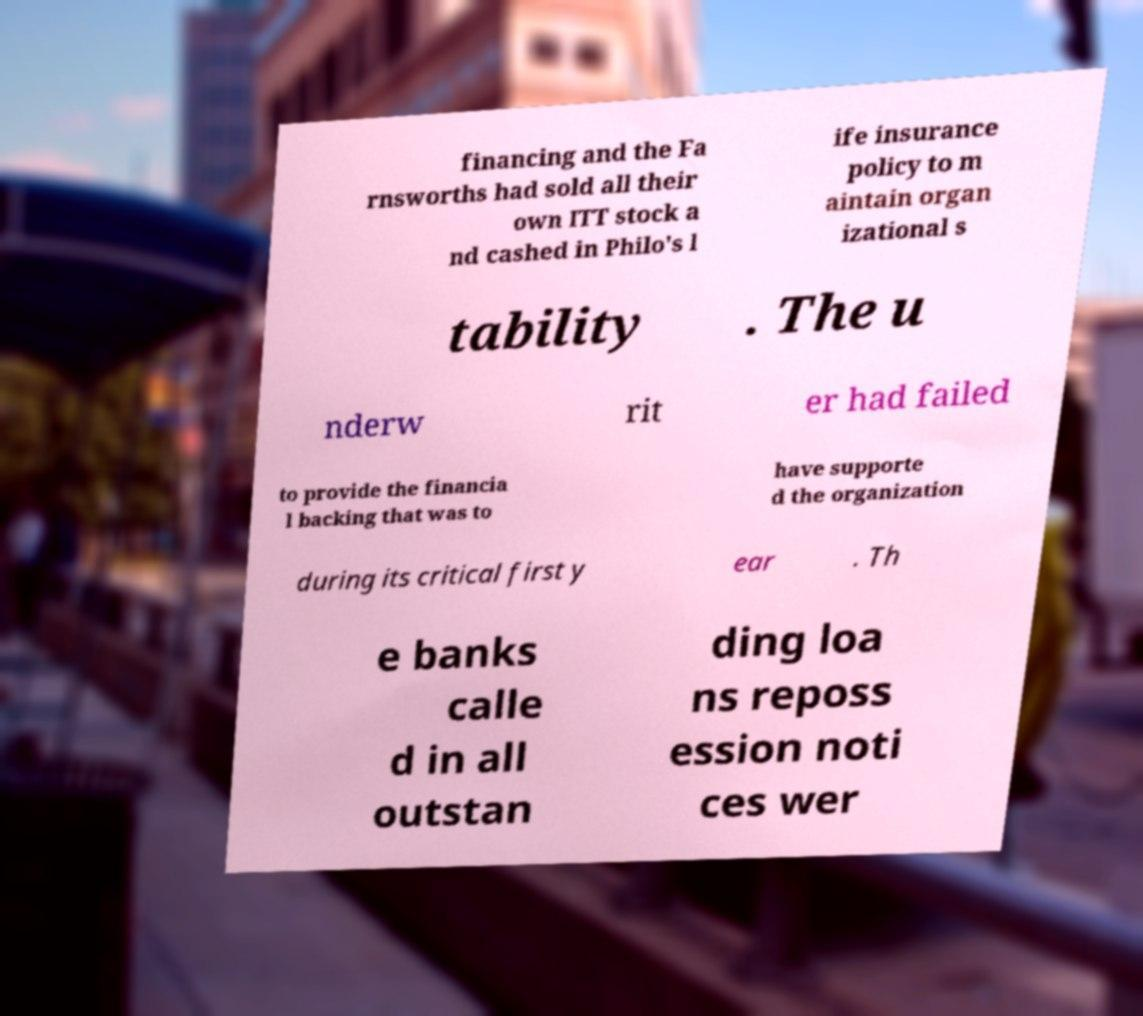Could you extract and type out the text from this image? financing and the Fa rnsworths had sold all their own ITT stock a nd cashed in Philo's l ife insurance policy to m aintain organ izational s tability . The u nderw rit er had failed to provide the financia l backing that was to have supporte d the organization during its critical first y ear . Th e banks calle d in all outstan ding loa ns reposs ession noti ces wer 